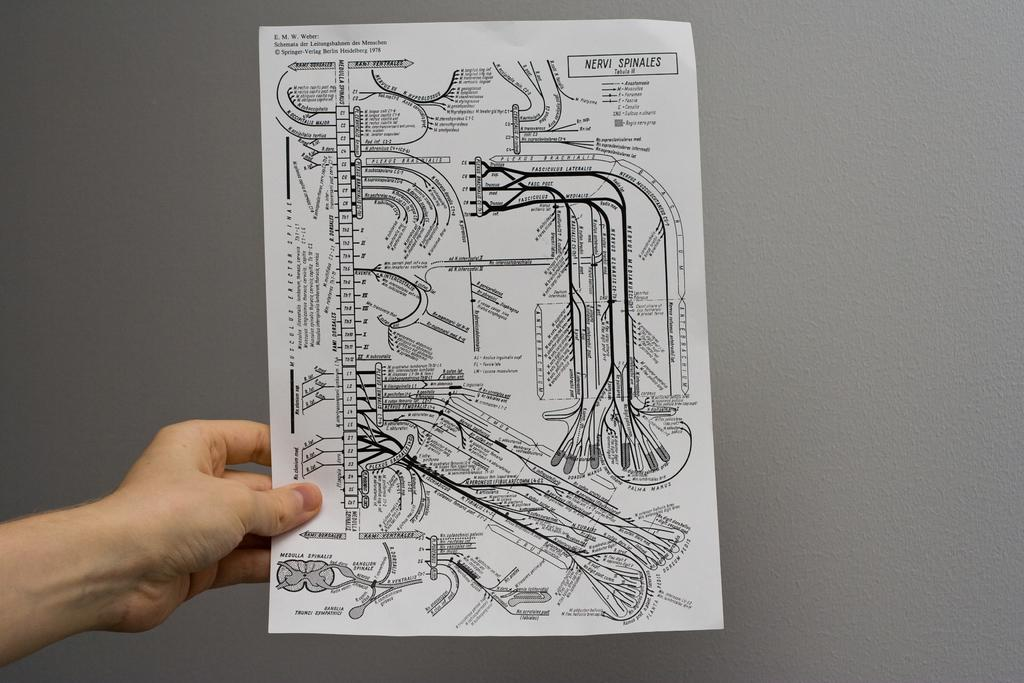What is present in the image? There is a person in the image. What is the person holding? The person is holding a paper. What type of pickle is the person holding in the image? There is no pickle present in the image; the person is holding a paper. How many wheels can be seen on the truck in the image? There is no truck present in the image. 